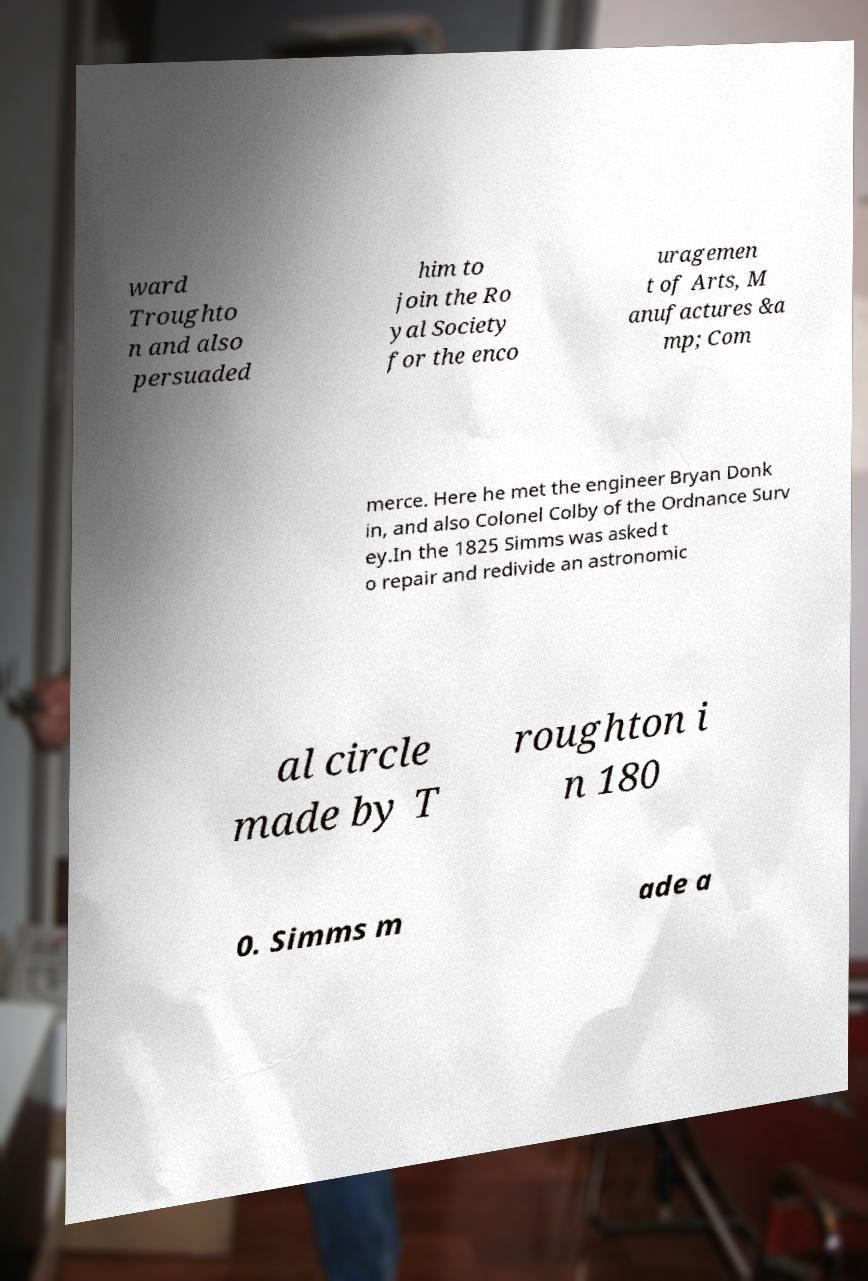There's text embedded in this image that I need extracted. Can you transcribe it verbatim? ward Troughto n and also persuaded him to join the Ro yal Society for the enco uragemen t of Arts, M anufactures &a mp; Com merce. Here he met the engineer Bryan Donk in, and also Colonel Colby of the Ordnance Surv ey.In the 1825 Simms was asked t o repair and redivide an astronomic al circle made by T roughton i n 180 0. Simms m ade a 